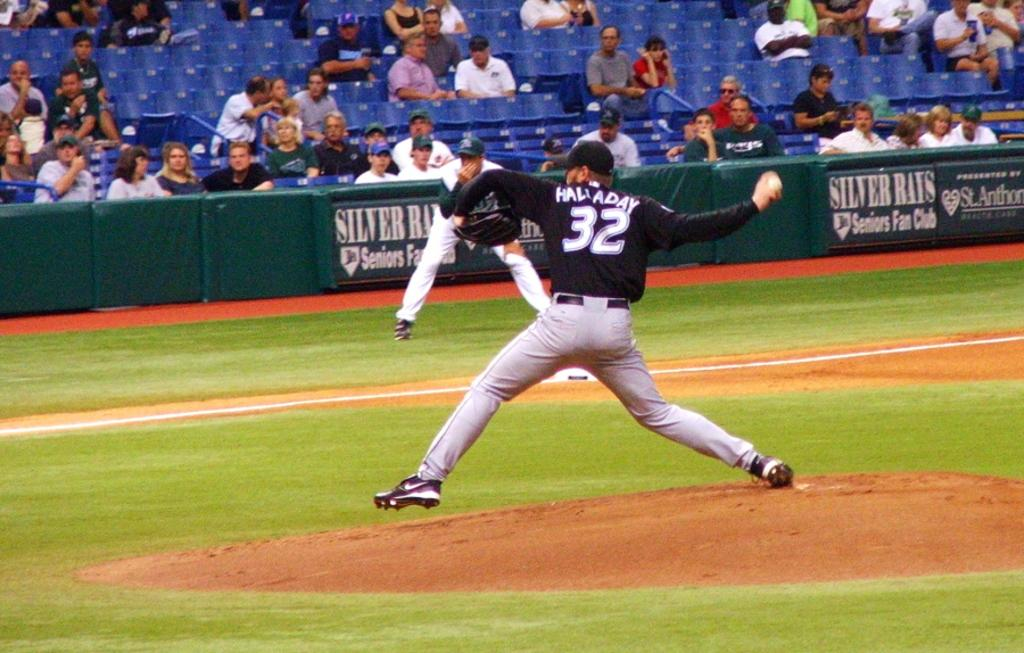<image>
Share a concise interpretation of the image provided. Baseball pitcher number 32 is about to pitch the ball from the mound. 